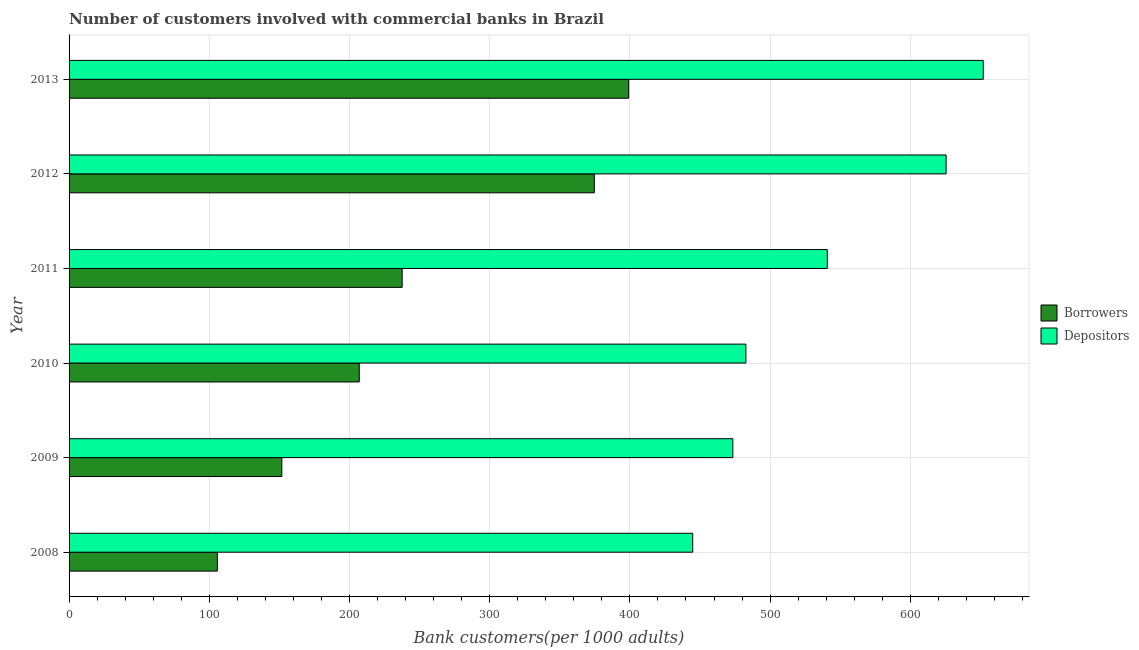How many different coloured bars are there?
Offer a very short reply. 2. Are the number of bars on each tick of the Y-axis equal?
Provide a short and direct response. Yes. In how many cases, is the number of bars for a given year not equal to the number of legend labels?
Your answer should be very brief. 0. What is the number of depositors in 2008?
Offer a very short reply. 444.8. Across all years, what is the maximum number of depositors?
Give a very brief answer. 652.04. Across all years, what is the minimum number of depositors?
Your answer should be very brief. 444.8. In which year was the number of depositors maximum?
Make the answer very short. 2013. In which year was the number of depositors minimum?
Your response must be concise. 2008. What is the total number of borrowers in the graph?
Provide a short and direct response. 1475.8. What is the difference between the number of borrowers in 2009 and that in 2012?
Offer a very short reply. -222.85. What is the difference between the number of depositors in 2009 and the number of borrowers in 2013?
Make the answer very short. 74.28. What is the average number of depositors per year?
Offer a terse response. 536.55. In the year 2013, what is the difference between the number of depositors and number of borrowers?
Keep it short and to the point. 252.9. What is the ratio of the number of depositors in 2010 to that in 2012?
Make the answer very short. 0.77. Is the number of borrowers in 2009 less than that in 2012?
Your answer should be very brief. Yes. What is the difference between the highest and the second highest number of borrowers?
Provide a succinct answer. 24.55. What is the difference between the highest and the lowest number of borrowers?
Keep it short and to the point. 293.36. What does the 1st bar from the top in 2011 represents?
Ensure brevity in your answer.  Depositors. What does the 1st bar from the bottom in 2013 represents?
Ensure brevity in your answer.  Borrowers. Are all the bars in the graph horizontal?
Your answer should be compact. Yes. How many years are there in the graph?
Your answer should be compact. 6. Does the graph contain grids?
Keep it short and to the point. Yes. How many legend labels are there?
Keep it short and to the point. 2. How are the legend labels stacked?
Offer a terse response. Vertical. What is the title of the graph?
Provide a short and direct response. Number of customers involved with commercial banks in Brazil. Does "Research and Development" appear as one of the legend labels in the graph?
Provide a succinct answer. No. What is the label or title of the X-axis?
Provide a short and direct response. Bank customers(per 1000 adults). What is the Bank customers(per 1000 adults) in Borrowers in 2008?
Give a very brief answer. 105.78. What is the Bank customers(per 1000 adults) of Depositors in 2008?
Your response must be concise. 444.8. What is the Bank customers(per 1000 adults) in Borrowers in 2009?
Provide a succinct answer. 151.74. What is the Bank customers(per 1000 adults) in Depositors in 2009?
Offer a terse response. 473.42. What is the Bank customers(per 1000 adults) of Borrowers in 2010?
Your answer should be compact. 206.97. What is the Bank customers(per 1000 adults) of Depositors in 2010?
Make the answer very short. 482.74. What is the Bank customers(per 1000 adults) of Borrowers in 2011?
Your answer should be compact. 237.57. What is the Bank customers(per 1000 adults) in Depositors in 2011?
Make the answer very short. 540.79. What is the Bank customers(per 1000 adults) of Borrowers in 2012?
Your answer should be very brief. 374.59. What is the Bank customers(per 1000 adults) of Depositors in 2012?
Make the answer very short. 625.53. What is the Bank customers(per 1000 adults) in Borrowers in 2013?
Make the answer very short. 399.14. What is the Bank customers(per 1000 adults) of Depositors in 2013?
Your answer should be compact. 652.04. Across all years, what is the maximum Bank customers(per 1000 adults) of Borrowers?
Ensure brevity in your answer.  399.14. Across all years, what is the maximum Bank customers(per 1000 adults) in Depositors?
Ensure brevity in your answer.  652.04. Across all years, what is the minimum Bank customers(per 1000 adults) of Borrowers?
Offer a terse response. 105.78. Across all years, what is the minimum Bank customers(per 1000 adults) in Depositors?
Your response must be concise. 444.8. What is the total Bank customers(per 1000 adults) in Borrowers in the graph?
Give a very brief answer. 1475.8. What is the total Bank customers(per 1000 adults) of Depositors in the graph?
Offer a terse response. 3219.33. What is the difference between the Bank customers(per 1000 adults) in Borrowers in 2008 and that in 2009?
Offer a terse response. -45.96. What is the difference between the Bank customers(per 1000 adults) in Depositors in 2008 and that in 2009?
Offer a terse response. -28.62. What is the difference between the Bank customers(per 1000 adults) of Borrowers in 2008 and that in 2010?
Give a very brief answer. -101.2. What is the difference between the Bank customers(per 1000 adults) in Depositors in 2008 and that in 2010?
Make the answer very short. -37.93. What is the difference between the Bank customers(per 1000 adults) in Borrowers in 2008 and that in 2011?
Offer a very short reply. -131.79. What is the difference between the Bank customers(per 1000 adults) in Depositors in 2008 and that in 2011?
Give a very brief answer. -95.99. What is the difference between the Bank customers(per 1000 adults) of Borrowers in 2008 and that in 2012?
Offer a very short reply. -268.82. What is the difference between the Bank customers(per 1000 adults) of Depositors in 2008 and that in 2012?
Your response must be concise. -180.73. What is the difference between the Bank customers(per 1000 adults) in Borrowers in 2008 and that in 2013?
Provide a succinct answer. -293.36. What is the difference between the Bank customers(per 1000 adults) in Depositors in 2008 and that in 2013?
Give a very brief answer. -207.23. What is the difference between the Bank customers(per 1000 adults) of Borrowers in 2009 and that in 2010?
Ensure brevity in your answer.  -55.23. What is the difference between the Bank customers(per 1000 adults) in Depositors in 2009 and that in 2010?
Make the answer very short. -9.32. What is the difference between the Bank customers(per 1000 adults) in Borrowers in 2009 and that in 2011?
Provide a succinct answer. -85.83. What is the difference between the Bank customers(per 1000 adults) in Depositors in 2009 and that in 2011?
Offer a terse response. -67.37. What is the difference between the Bank customers(per 1000 adults) of Borrowers in 2009 and that in 2012?
Make the answer very short. -222.85. What is the difference between the Bank customers(per 1000 adults) of Depositors in 2009 and that in 2012?
Your response must be concise. -152.11. What is the difference between the Bank customers(per 1000 adults) in Borrowers in 2009 and that in 2013?
Offer a terse response. -247.4. What is the difference between the Bank customers(per 1000 adults) in Depositors in 2009 and that in 2013?
Give a very brief answer. -178.62. What is the difference between the Bank customers(per 1000 adults) in Borrowers in 2010 and that in 2011?
Keep it short and to the point. -30.59. What is the difference between the Bank customers(per 1000 adults) in Depositors in 2010 and that in 2011?
Ensure brevity in your answer.  -58.05. What is the difference between the Bank customers(per 1000 adults) in Borrowers in 2010 and that in 2012?
Keep it short and to the point. -167.62. What is the difference between the Bank customers(per 1000 adults) in Depositors in 2010 and that in 2012?
Your answer should be very brief. -142.79. What is the difference between the Bank customers(per 1000 adults) of Borrowers in 2010 and that in 2013?
Provide a short and direct response. -192.17. What is the difference between the Bank customers(per 1000 adults) of Depositors in 2010 and that in 2013?
Keep it short and to the point. -169.3. What is the difference between the Bank customers(per 1000 adults) in Borrowers in 2011 and that in 2012?
Ensure brevity in your answer.  -137.03. What is the difference between the Bank customers(per 1000 adults) of Depositors in 2011 and that in 2012?
Offer a very short reply. -84.74. What is the difference between the Bank customers(per 1000 adults) in Borrowers in 2011 and that in 2013?
Your response must be concise. -161.57. What is the difference between the Bank customers(per 1000 adults) of Depositors in 2011 and that in 2013?
Keep it short and to the point. -111.25. What is the difference between the Bank customers(per 1000 adults) of Borrowers in 2012 and that in 2013?
Ensure brevity in your answer.  -24.55. What is the difference between the Bank customers(per 1000 adults) in Depositors in 2012 and that in 2013?
Ensure brevity in your answer.  -26.51. What is the difference between the Bank customers(per 1000 adults) in Borrowers in 2008 and the Bank customers(per 1000 adults) in Depositors in 2009?
Your answer should be compact. -367.64. What is the difference between the Bank customers(per 1000 adults) of Borrowers in 2008 and the Bank customers(per 1000 adults) of Depositors in 2010?
Provide a short and direct response. -376.96. What is the difference between the Bank customers(per 1000 adults) in Borrowers in 2008 and the Bank customers(per 1000 adults) in Depositors in 2011?
Offer a terse response. -435.01. What is the difference between the Bank customers(per 1000 adults) in Borrowers in 2008 and the Bank customers(per 1000 adults) in Depositors in 2012?
Keep it short and to the point. -519.75. What is the difference between the Bank customers(per 1000 adults) of Borrowers in 2008 and the Bank customers(per 1000 adults) of Depositors in 2013?
Your answer should be very brief. -546.26. What is the difference between the Bank customers(per 1000 adults) of Borrowers in 2009 and the Bank customers(per 1000 adults) of Depositors in 2010?
Provide a short and direct response. -331. What is the difference between the Bank customers(per 1000 adults) of Borrowers in 2009 and the Bank customers(per 1000 adults) of Depositors in 2011?
Ensure brevity in your answer.  -389.05. What is the difference between the Bank customers(per 1000 adults) in Borrowers in 2009 and the Bank customers(per 1000 adults) in Depositors in 2012?
Offer a very short reply. -473.79. What is the difference between the Bank customers(per 1000 adults) of Borrowers in 2009 and the Bank customers(per 1000 adults) of Depositors in 2013?
Your answer should be very brief. -500.3. What is the difference between the Bank customers(per 1000 adults) in Borrowers in 2010 and the Bank customers(per 1000 adults) in Depositors in 2011?
Your answer should be compact. -333.82. What is the difference between the Bank customers(per 1000 adults) in Borrowers in 2010 and the Bank customers(per 1000 adults) in Depositors in 2012?
Ensure brevity in your answer.  -418.56. What is the difference between the Bank customers(per 1000 adults) of Borrowers in 2010 and the Bank customers(per 1000 adults) of Depositors in 2013?
Provide a succinct answer. -445.06. What is the difference between the Bank customers(per 1000 adults) in Borrowers in 2011 and the Bank customers(per 1000 adults) in Depositors in 2012?
Your response must be concise. -387.96. What is the difference between the Bank customers(per 1000 adults) in Borrowers in 2011 and the Bank customers(per 1000 adults) in Depositors in 2013?
Keep it short and to the point. -414.47. What is the difference between the Bank customers(per 1000 adults) of Borrowers in 2012 and the Bank customers(per 1000 adults) of Depositors in 2013?
Provide a succinct answer. -277.44. What is the average Bank customers(per 1000 adults) of Borrowers per year?
Your answer should be very brief. 245.97. What is the average Bank customers(per 1000 adults) in Depositors per year?
Give a very brief answer. 536.55. In the year 2008, what is the difference between the Bank customers(per 1000 adults) in Borrowers and Bank customers(per 1000 adults) in Depositors?
Make the answer very short. -339.03. In the year 2009, what is the difference between the Bank customers(per 1000 adults) of Borrowers and Bank customers(per 1000 adults) of Depositors?
Your answer should be very brief. -321.68. In the year 2010, what is the difference between the Bank customers(per 1000 adults) in Borrowers and Bank customers(per 1000 adults) in Depositors?
Ensure brevity in your answer.  -275.76. In the year 2011, what is the difference between the Bank customers(per 1000 adults) of Borrowers and Bank customers(per 1000 adults) of Depositors?
Ensure brevity in your answer.  -303.22. In the year 2012, what is the difference between the Bank customers(per 1000 adults) in Borrowers and Bank customers(per 1000 adults) in Depositors?
Give a very brief answer. -250.94. In the year 2013, what is the difference between the Bank customers(per 1000 adults) of Borrowers and Bank customers(per 1000 adults) of Depositors?
Provide a short and direct response. -252.9. What is the ratio of the Bank customers(per 1000 adults) in Borrowers in 2008 to that in 2009?
Your answer should be compact. 0.7. What is the ratio of the Bank customers(per 1000 adults) in Depositors in 2008 to that in 2009?
Provide a succinct answer. 0.94. What is the ratio of the Bank customers(per 1000 adults) of Borrowers in 2008 to that in 2010?
Ensure brevity in your answer.  0.51. What is the ratio of the Bank customers(per 1000 adults) in Depositors in 2008 to that in 2010?
Offer a terse response. 0.92. What is the ratio of the Bank customers(per 1000 adults) in Borrowers in 2008 to that in 2011?
Provide a short and direct response. 0.45. What is the ratio of the Bank customers(per 1000 adults) of Depositors in 2008 to that in 2011?
Ensure brevity in your answer.  0.82. What is the ratio of the Bank customers(per 1000 adults) in Borrowers in 2008 to that in 2012?
Keep it short and to the point. 0.28. What is the ratio of the Bank customers(per 1000 adults) in Depositors in 2008 to that in 2012?
Offer a very short reply. 0.71. What is the ratio of the Bank customers(per 1000 adults) in Borrowers in 2008 to that in 2013?
Provide a short and direct response. 0.27. What is the ratio of the Bank customers(per 1000 adults) of Depositors in 2008 to that in 2013?
Your answer should be compact. 0.68. What is the ratio of the Bank customers(per 1000 adults) in Borrowers in 2009 to that in 2010?
Give a very brief answer. 0.73. What is the ratio of the Bank customers(per 1000 adults) in Depositors in 2009 to that in 2010?
Offer a terse response. 0.98. What is the ratio of the Bank customers(per 1000 adults) of Borrowers in 2009 to that in 2011?
Your answer should be compact. 0.64. What is the ratio of the Bank customers(per 1000 adults) of Depositors in 2009 to that in 2011?
Your answer should be very brief. 0.88. What is the ratio of the Bank customers(per 1000 adults) of Borrowers in 2009 to that in 2012?
Your answer should be compact. 0.41. What is the ratio of the Bank customers(per 1000 adults) in Depositors in 2009 to that in 2012?
Offer a terse response. 0.76. What is the ratio of the Bank customers(per 1000 adults) in Borrowers in 2009 to that in 2013?
Your answer should be very brief. 0.38. What is the ratio of the Bank customers(per 1000 adults) in Depositors in 2009 to that in 2013?
Keep it short and to the point. 0.73. What is the ratio of the Bank customers(per 1000 adults) of Borrowers in 2010 to that in 2011?
Give a very brief answer. 0.87. What is the ratio of the Bank customers(per 1000 adults) in Depositors in 2010 to that in 2011?
Provide a short and direct response. 0.89. What is the ratio of the Bank customers(per 1000 adults) in Borrowers in 2010 to that in 2012?
Your answer should be compact. 0.55. What is the ratio of the Bank customers(per 1000 adults) in Depositors in 2010 to that in 2012?
Give a very brief answer. 0.77. What is the ratio of the Bank customers(per 1000 adults) of Borrowers in 2010 to that in 2013?
Give a very brief answer. 0.52. What is the ratio of the Bank customers(per 1000 adults) in Depositors in 2010 to that in 2013?
Provide a succinct answer. 0.74. What is the ratio of the Bank customers(per 1000 adults) of Borrowers in 2011 to that in 2012?
Make the answer very short. 0.63. What is the ratio of the Bank customers(per 1000 adults) in Depositors in 2011 to that in 2012?
Make the answer very short. 0.86. What is the ratio of the Bank customers(per 1000 adults) in Borrowers in 2011 to that in 2013?
Provide a succinct answer. 0.6. What is the ratio of the Bank customers(per 1000 adults) of Depositors in 2011 to that in 2013?
Your response must be concise. 0.83. What is the ratio of the Bank customers(per 1000 adults) of Borrowers in 2012 to that in 2013?
Offer a terse response. 0.94. What is the ratio of the Bank customers(per 1000 adults) of Depositors in 2012 to that in 2013?
Make the answer very short. 0.96. What is the difference between the highest and the second highest Bank customers(per 1000 adults) of Borrowers?
Provide a short and direct response. 24.55. What is the difference between the highest and the second highest Bank customers(per 1000 adults) of Depositors?
Your answer should be very brief. 26.51. What is the difference between the highest and the lowest Bank customers(per 1000 adults) of Borrowers?
Your answer should be compact. 293.36. What is the difference between the highest and the lowest Bank customers(per 1000 adults) of Depositors?
Keep it short and to the point. 207.23. 